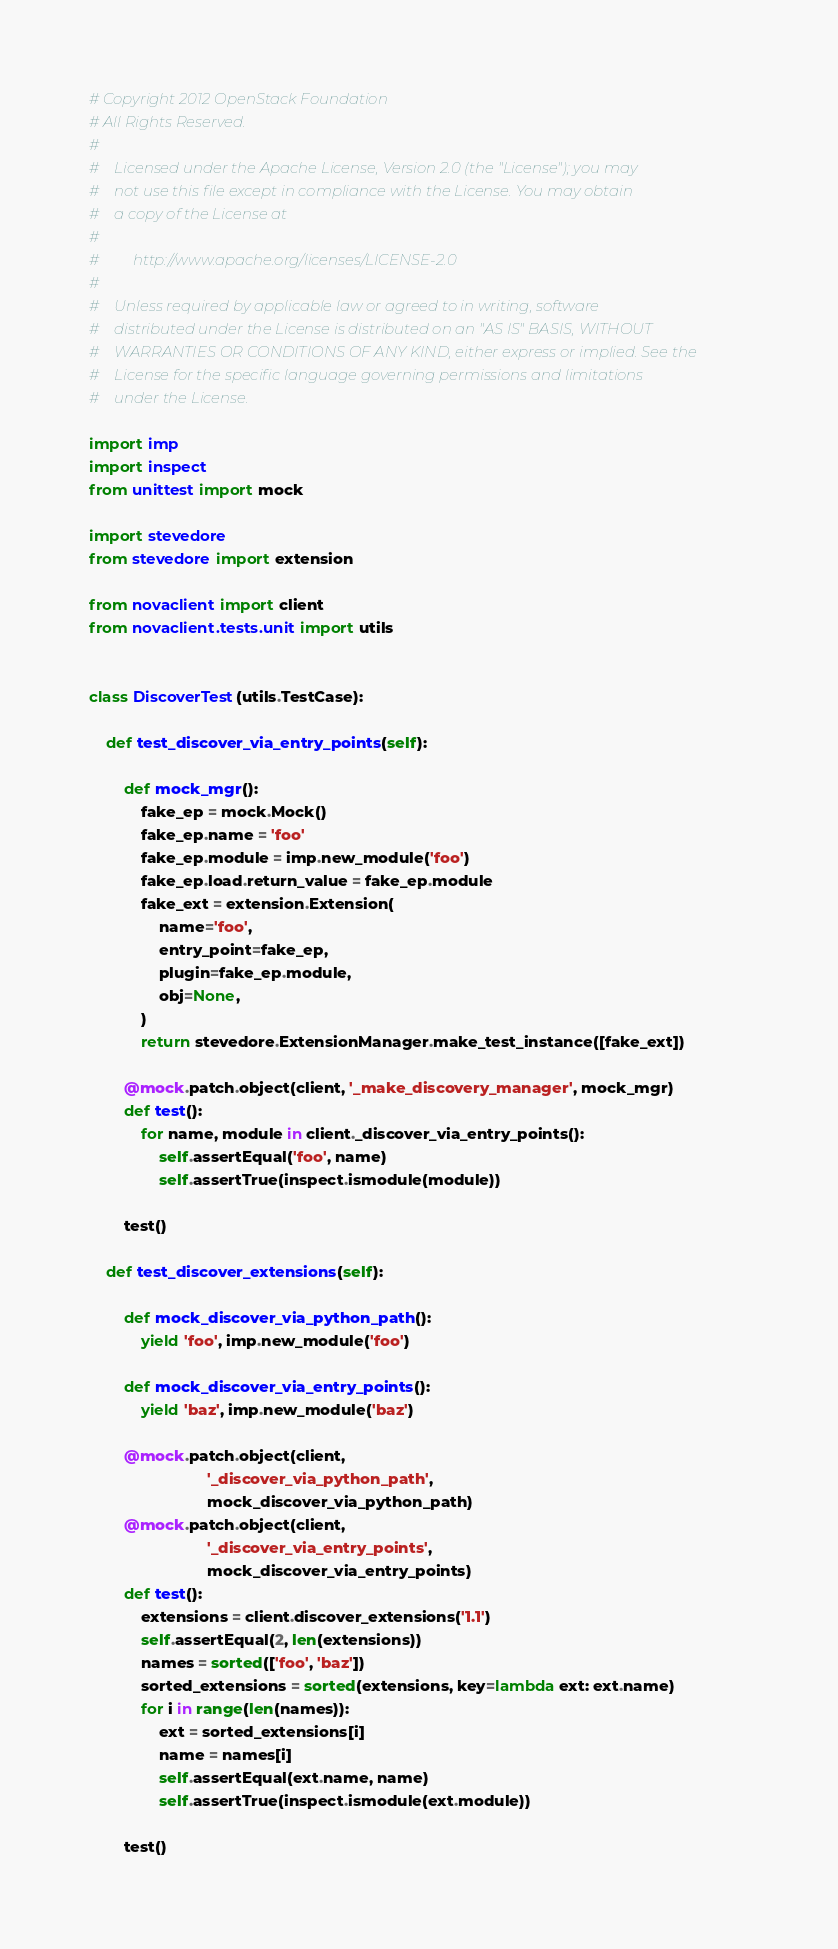Convert code to text. <code><loc_0><loc_0><loc_500><loc_500><_Python_># Copyright 2012 OpenStack Foundation
# All Rights Reserved.
#
#    Licensed under the Apache License, Version 2.0 (the "License"); you may
#    not use this file except in compliance with the License. You may obtain
#    a copy of the License at
#
#         http://www.apache.org/licenses/LICENSE-2.0
#
#    Unless required by applicable law or agreed to in writing, software
#    distributed under the License is distributed on an "AS IS" BASIS, WITHOUT
#    WARRANTIES OR CONDITIONS OF ANY KIND, either express or implied. See the
#    License for the specific language governing permissions and limitations
#    under the License.

import imp
import inspect
from unittest import mock

import stevedore
from stevedore import extension

from novaclient import client
from novaclient.tests.unit import utils


class DiscoverTest(utils.TestCase):

    def test_discover_via_entry_points(self):

        def mock_mgr():
            fake_ep = mock.Mock()
            fake_ep.name = 'foo'
            fake_ep.module = imp.new_module('foo')
            fake_ep.load.return_value = fake_ep.module
            fake_ext = extension.Extension(
                name='foo',
                entry_point=fake_ep,
                plugin=fake_ep.module,
                obj=None,
            )
            return stevedore.ExtensionManager.make_test_instance([fake_ext])

        @mock.patch.object(client, '_make_discovery_manager', mock_mgr)
        def test():
            for name, module in client._discover_via_entry_points():
                self.assertEqual('foo', name)
                self.assertTrue(inspect.ismodule(module))

        test()

    def test_discover_extensions(self):

        def mock_discover_via_python_path():
            yield 'foo', imp.new_module('foo')

        def mock_discover_via_entry_points():
            yield 'baz', imp.new_module('baz')

        @mock.patch.object(client,
                           '_discover_via_python_path',
                           mock_discover_via_python_path)
        @mock.patch.object(client,
                           '_discover_via_entry_points',
                           mock_discover_via_entry_points)
        def test():
            extensions = client.discover_extensions('1.1')
            self.assertEqual(2, len(extensions))
            names = sorted(['foo', 'baz'])
            sorted_extensions = sorted(extensions, key=lambda ext: ext.name)
            for i in range(len(names)):
                ext = sorted_extensions[i]
                name = names[i]
                self.assertEqual(ext.name, name)
                self.assertTrue(inspect.ismodule(ext.module))

        test()
</code> 